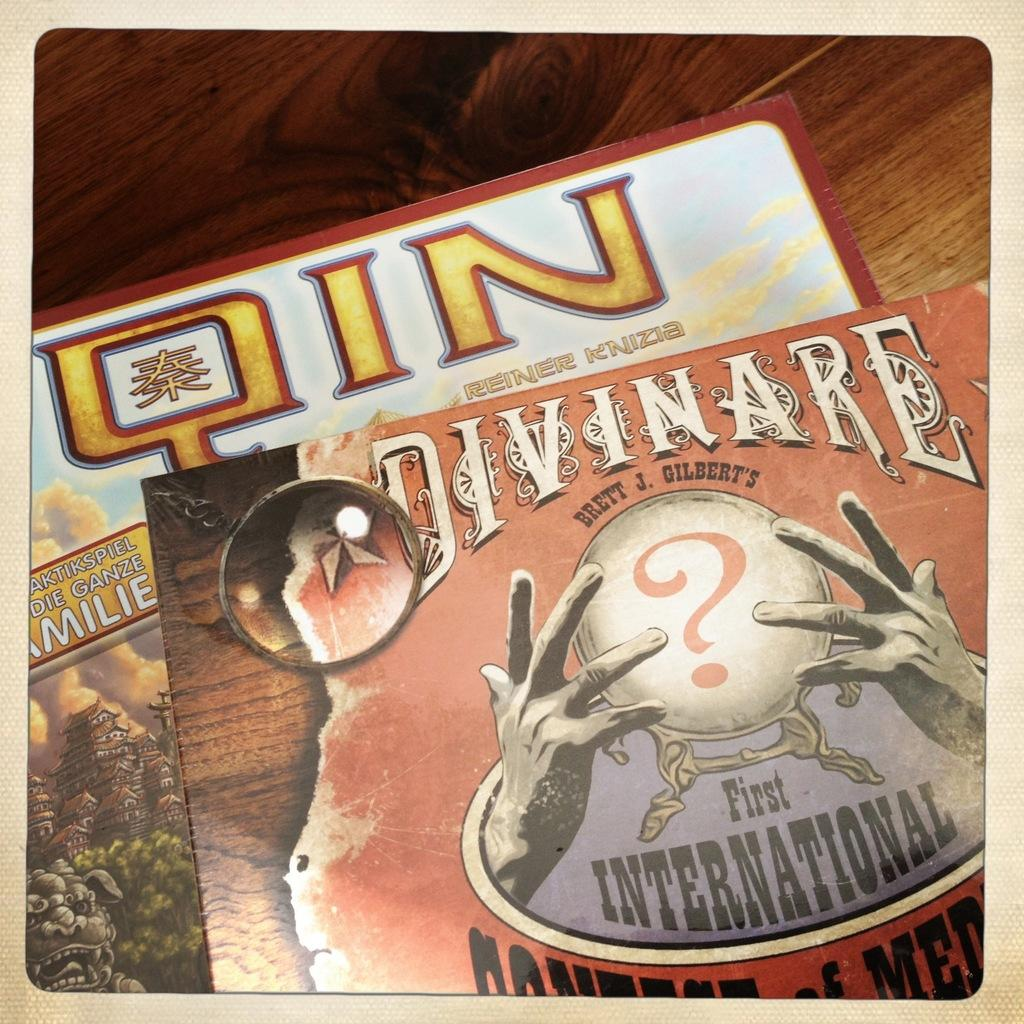<image>
Write a terse but informative summary of the picture. Two covers, one is entitle Qin an the other First International. 